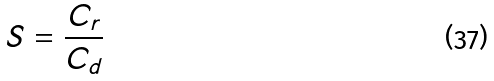Convert formula to latex. <formula><loc_0><loc_0><loc_500><loc_500>S = \frac { C _ { r } } { C _ { d } }</formula> 